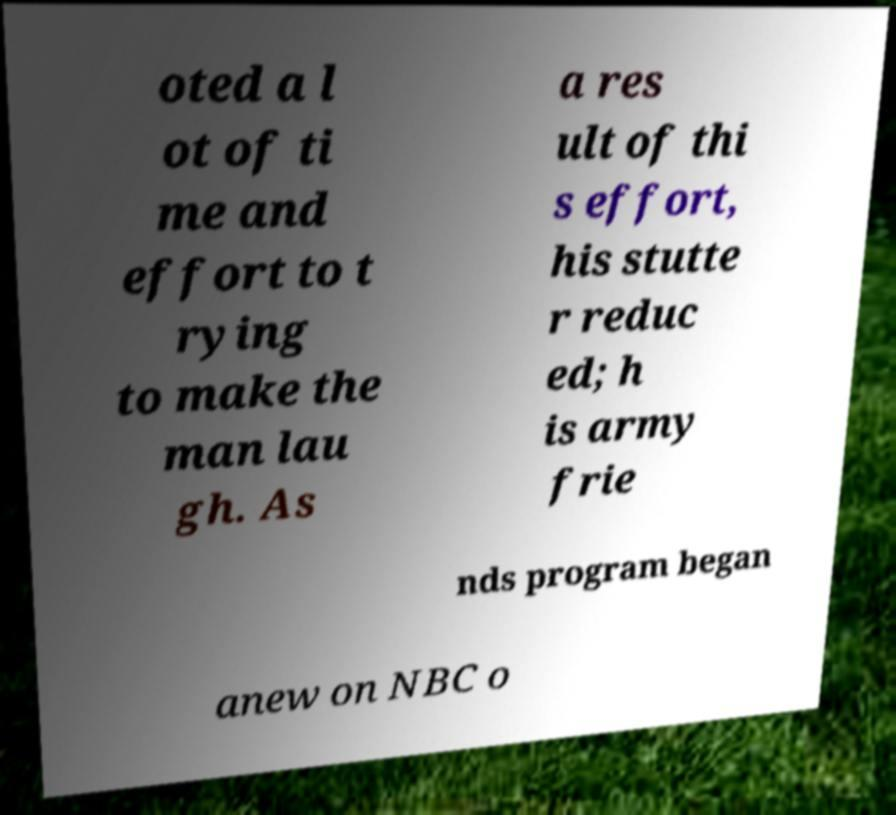What messages or text are displayed in this image? I need them in a readable, typed format. oted a l ot of ti me and effort to t rying to make the man lau gh. As a res ult of thi s effort, his stutte r reduc ed; h is army frie nds program began anew on NBC o 